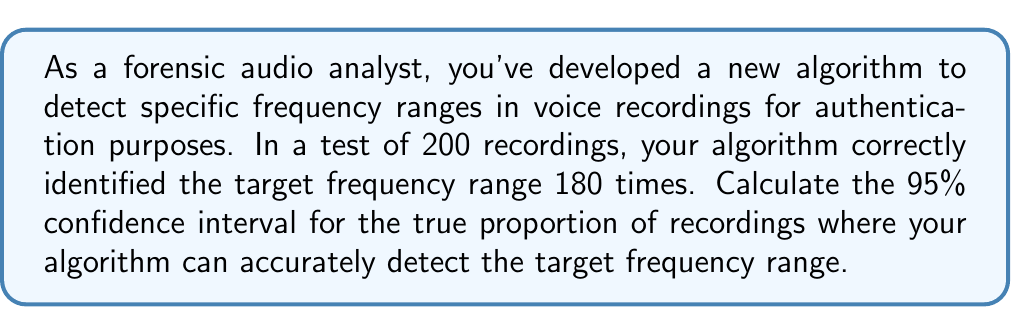Show me your answer to this math problem. To calculate the confidence interval, we'll use the formula for a binomial proportion confidence interval:

$$p \pm z \sqrt{\frac{p(1-p)}{n}}$$

Where:
$p$ = sample proportion
$z$ = z-score for desired confidence level
$n$ = sample size

Step 1: Calculate the sample proportion (p)
$p = \frac{\text{number of successes}}{\text{total number of trials}} = \frac{180}{200} = 0.9$

Step 2: Determine the z-score for 95% confidence level
For 95% confidence, $z = 1.96$

Step 3: Calculate the margin of error
$$\text{Margin of Error} = z \sqrt{\frac{p(1-p)}{n}}$$
$$= 1.96 \sqrt{\frac{0.9(1-0.9)}{200}}$$
$$= 1.96 \sqrt{\frac{0.09}{200}}$$
$$= 1.96 \sqrt{0.00045}$$
$$\approx 0.0415$$

Step 4: Calculate the lower and upper bounds of the confidence interval
Lower bound: $0.9 - 0.0415 = 0.8585$
Upper bound: $0.9 + 0.0415 = 0.9415$

Therefore, the 95% confidence interval is (0.8585, 0.9415) or approximately (85.85%, 94.15%).
Answer: (0.8585, 0.9415) 